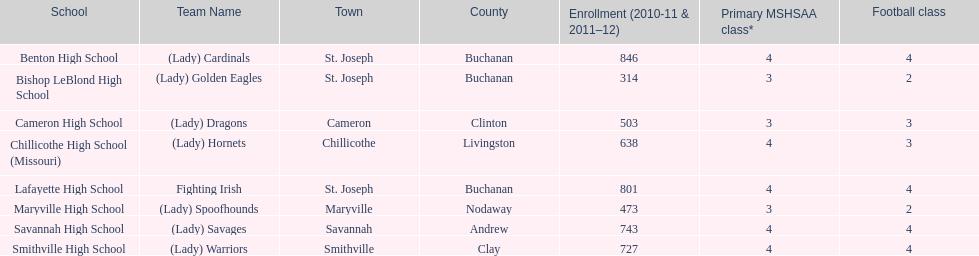What school in midland empire conference has 846 students enrolled? Benton High School. What school has 314 students enrolled? Bishop LeBlond High School. What school had 638 students enrolled? Chillicothe High School (Missouri). 